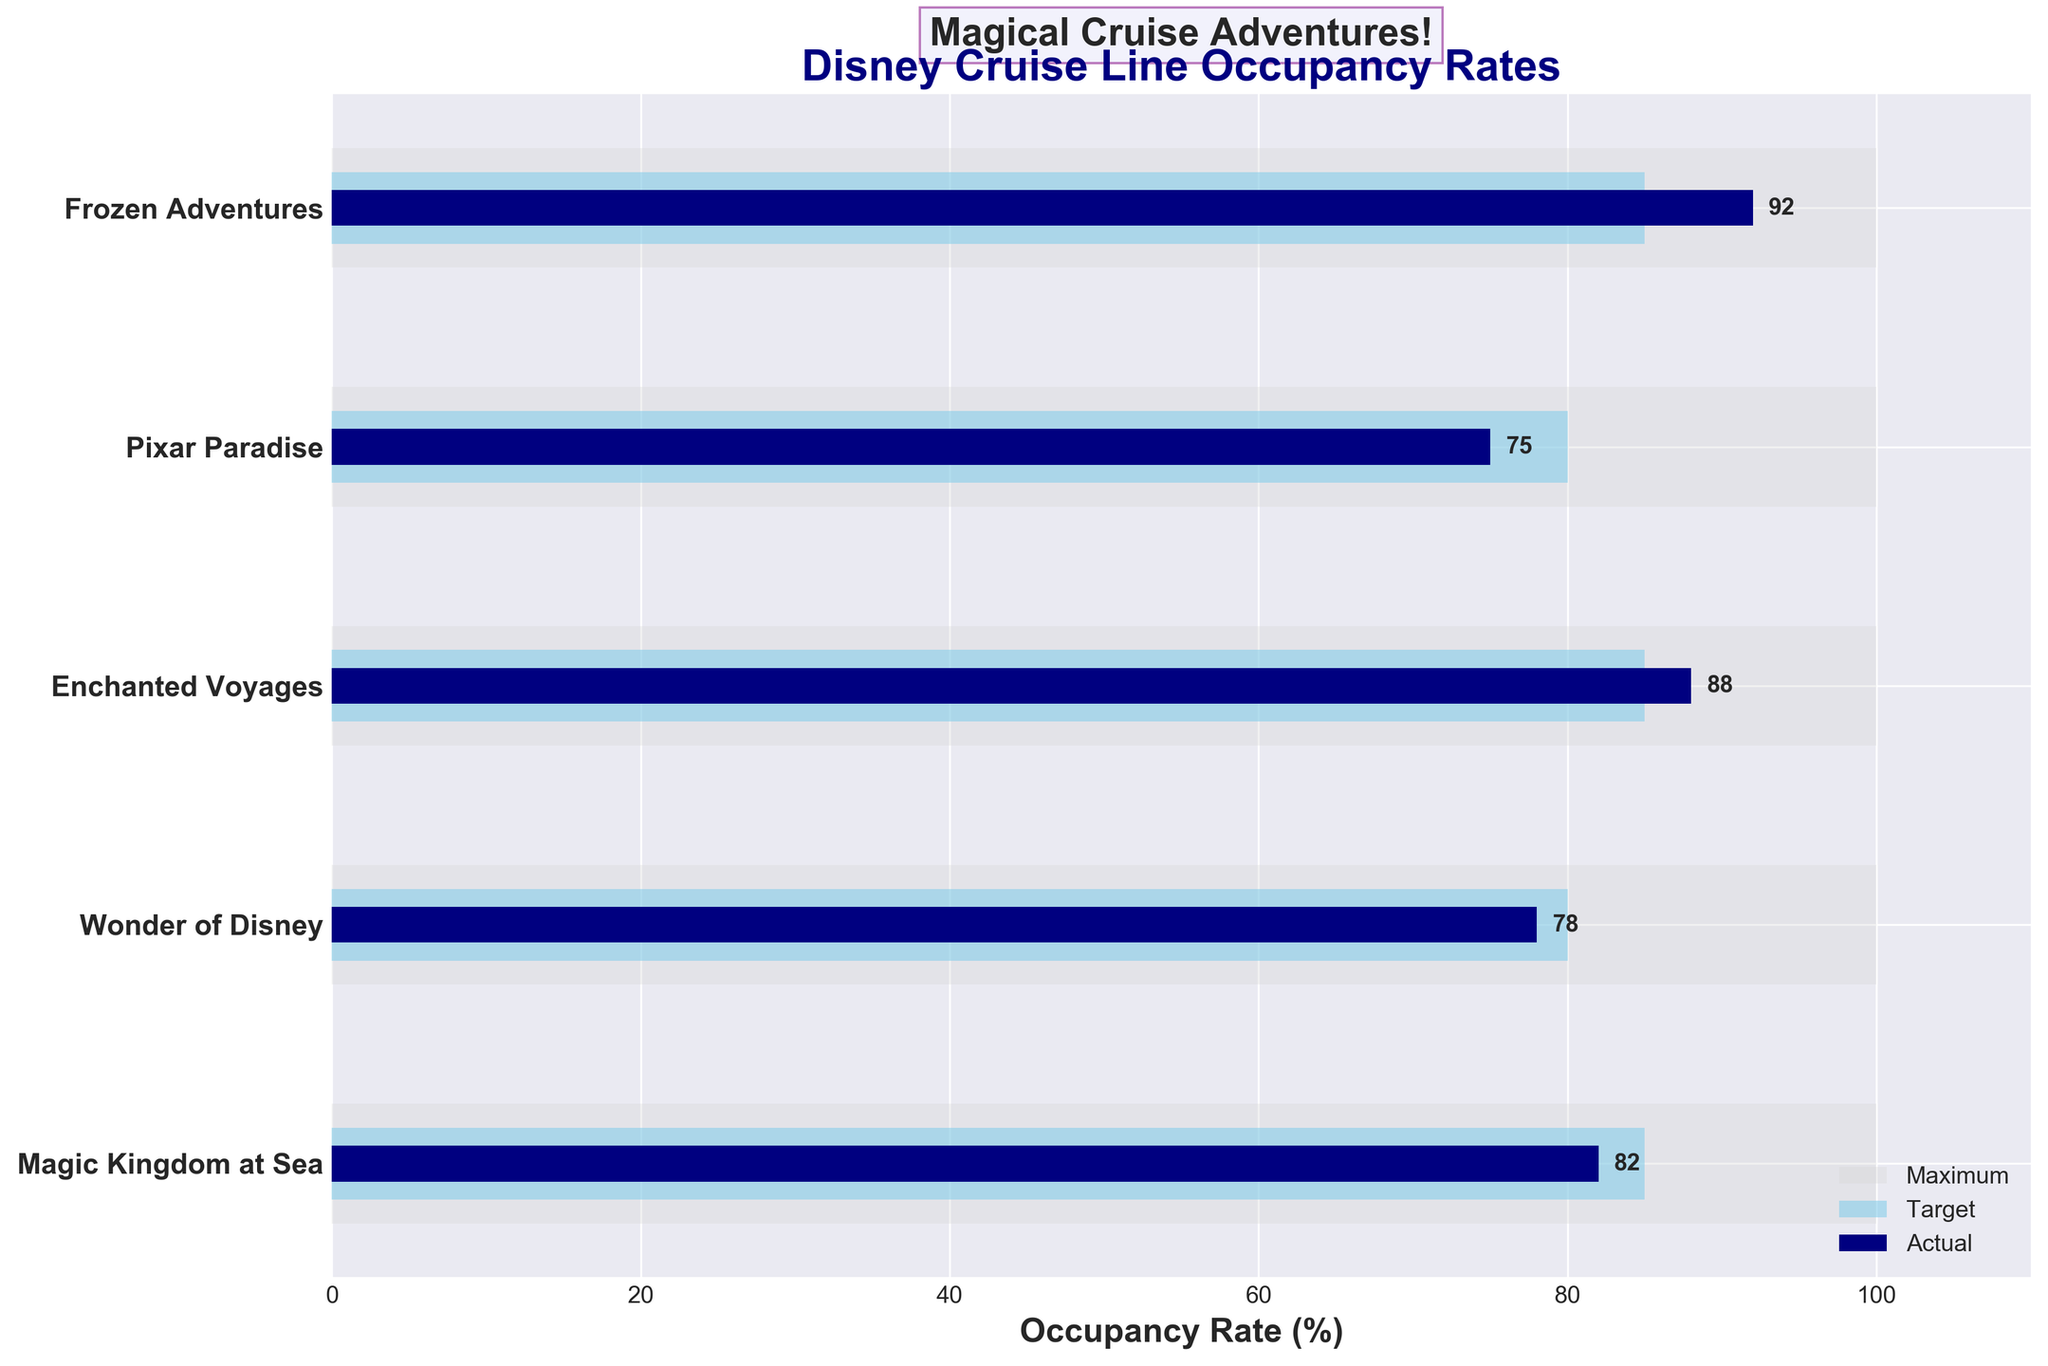Who has the highest occupancy rate among the cruises? Enchanted Voyages has an occupancy rate of 92%, which is higher than all other cruises listed in the figure.
Answer: Frozen Adventures What is the difference between the target and actual occupancy rates for Pixar Paradise? For Pixar Paradise, the target is 80% and the actual is 75%, so the difference is 80% - 75% = 5%.
Answer: 5% How many cruises meet or exceed their occupancy targets? We need to compare the actual occupancy rate against the target occupancy rate for each cruise. Magic Kingdom at Sea (82% vs. 85%, below target), Wonder of Disney (78% vs. 80%, below target), Enchanted Voyages (92% vs. 85%, above target), Pixar Paradise (75% vs. 80%, below target), and Frozen Adventures (92% vs. 85%, above target). Two cruises meet or exceed their targets.
Answer: 2 Which cruise has the closest actual occupancy rate to its target? We calculate the absolute difference between the actual and target for each cruise and find that Magic Kingdom at Sea has a difference of 3% (85% - 82%), the smallest difference among all entries.
Answer: Magic Kingdom at Sea What are the total occupancy rates across all cruises? Add the actual occupancy rates: 82% (Magic Kingdom at Sea) + 78% (Wonder of Disney) + 92% (Enchanted Voyages) + 75% (Pixar Paradise) + 92% (Frozen Adventures) = 419%
Answer: 419% Which cruise has the largest gap between maximum and actual occupancy rates? Calculate the difference between the maximum and actual for each cruise: Magic Kingdom at Sea (100% - 82% = 18%), Wonder of Disney (100% - 78% = 22%), Enchanted Voyages (100% - 88% = 12%), Pixar Paradise (100% - 75% = 25%), Frozen Adventures (100% - 92% = 8%). Pixar Paradise has the largest gap at 25%.
Answer: Pixar Paradise What is the average target occupancy rate for the listed cruises? Add the target rates and divide by the number of cruises: (85% + 80% + 85% + 80% + 85%) / 5 = 83%.
Answer: 83% Which cruise has an actual occupancy rate higher than 90%? Frozen Adventures has an actual occupancy rate of 92%, meeting the criteria of being higher than 90%.
Answer: Frozen Adventures What is the difference in actual occupancy rates between the highest and lowest rates? The highest actual occupancy rate is Frozen Adventures at 92%, and the lowest is Pixar Paradise at 75%. The difference is 92% - 75% = 17%.
Answer: 17% What are the names of the cruises that have actual rates within 5% of their targets? We need to find cruises where the difference between actual and target rates is 5% or less. For the given data: Magic Kingdom at Sea (3% difference), Enchanted Voyages (3% difference), and Pixar Paradise (5% difference) meet this criteria.
Answer: Magic Kingdom at Sea, Enchanted Voyages, Pixar Paradise 